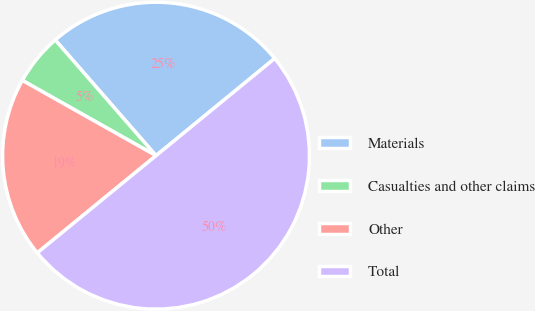<chart> <loc_0><loc_0><loc_500><loc_500><pie_chart><fcel>Materials<fcel>Casualties and other claims<fcel>Other<fcel>Total<nl><fcel>25.48%<fcel>5.43%<fcel>19.08%<fcel>50.0%<nl></chart> 